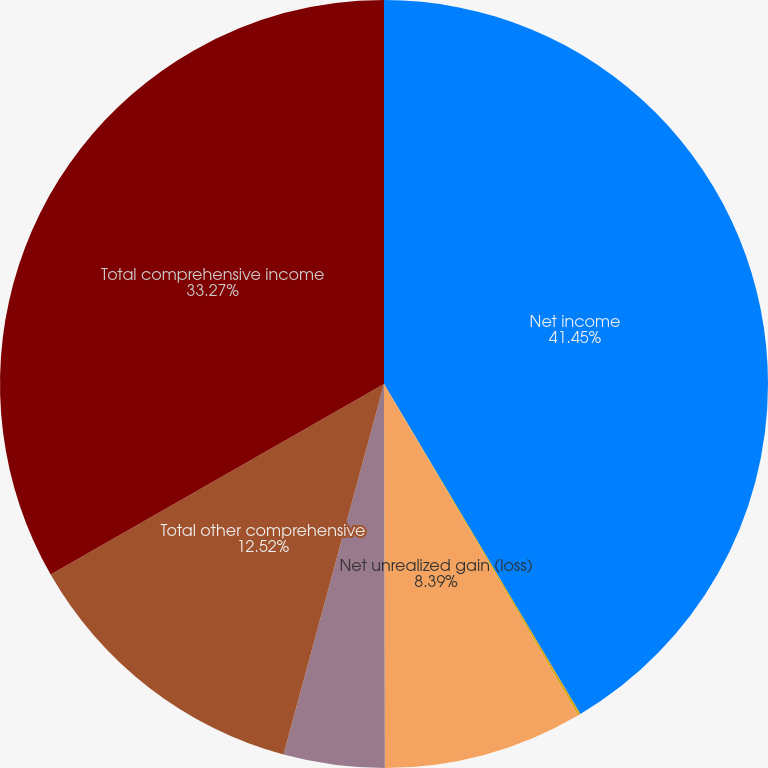Convert chart to OTSL. <chart><loc_0><loc_0><loc_500><loc_500><pie_chart><fcel>Net income<fcel>Shipboard Retirement Plan<fcel>Net unrealized gain (loss)<fcel>Amount realized and<fcel>Total other comprehensive<fcel>Total comprehensive income<nl><fcel>41.46%<fcel>0.12%<fcel>8.39%<fcel>4.25%<fcel>12.52%<fcel>33.27%<nl></chart> 